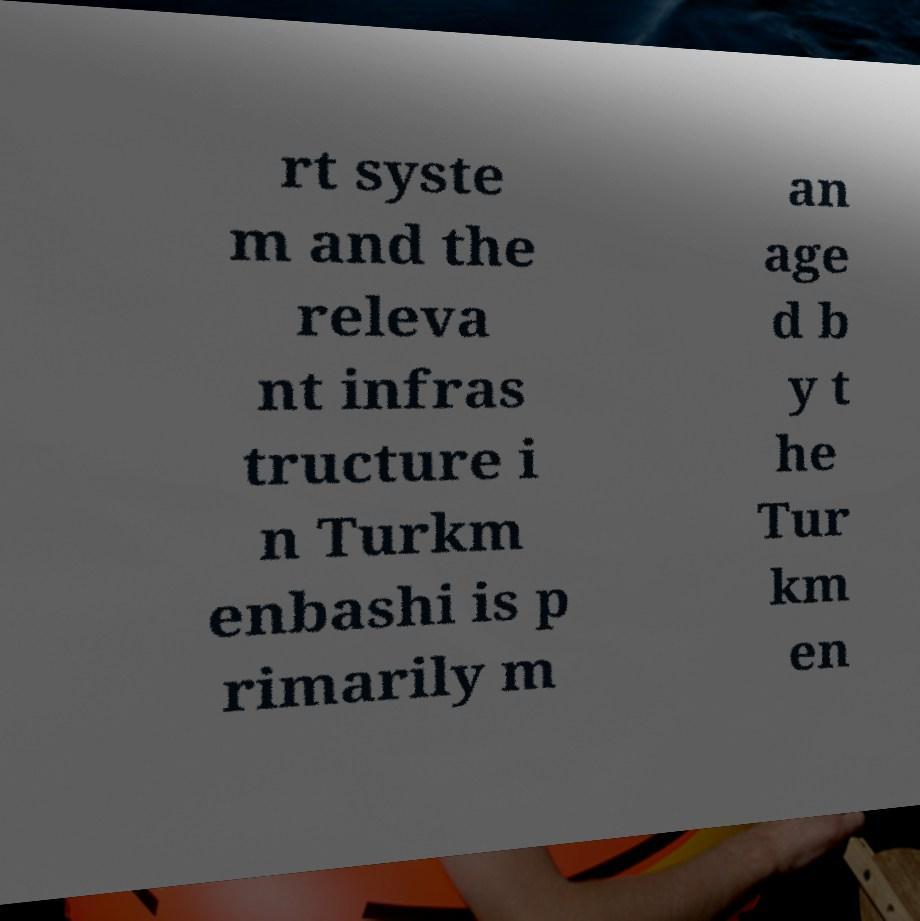I need the written content from this picture converted into text. Can you do that? rt syste m and the releva nt infras tructure i n Turkm enbashi is p rimarily m an age d b y t he Tur km en 